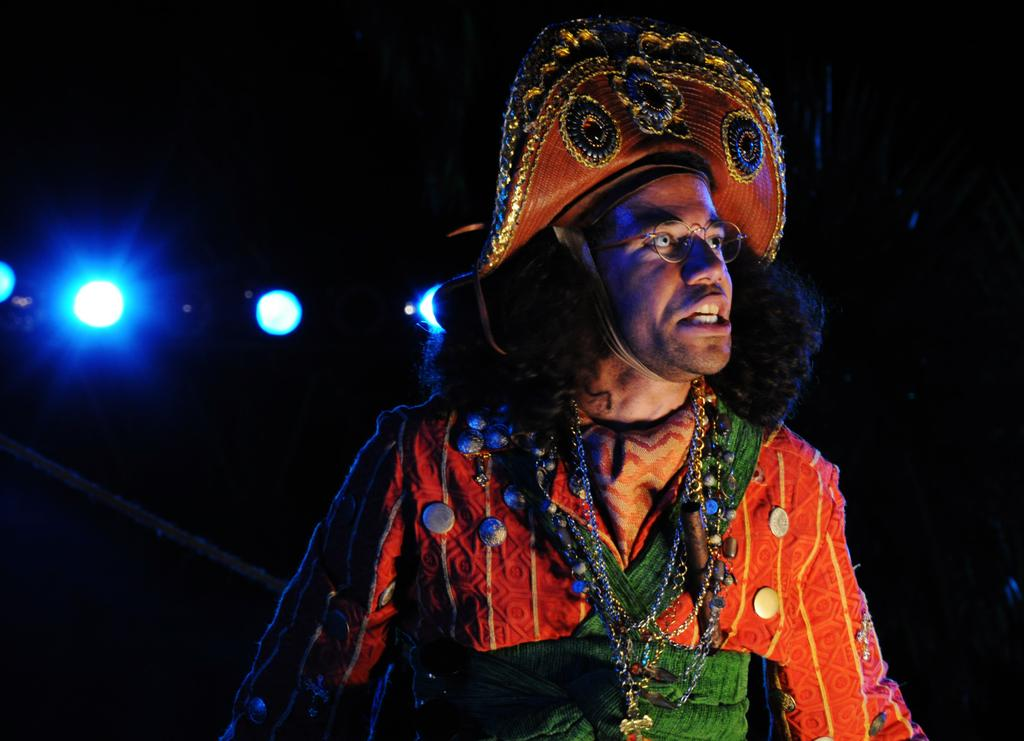Who is present in the image? There is a man in the image. What is the man wearing? The man is wearing a fancy dress. What can be seen behind the man in the image? There is a dark background in the image. What can be seen in addition to the man and the background? There are lights visible in the image. Are there any visible flesh wounds on the man in the image? There is no indication of any flesh wounds on the man in the image. Can you see any cobwebs in the image? There is no mention of cobwebs in the image, and they are not visible in the provided facts. 